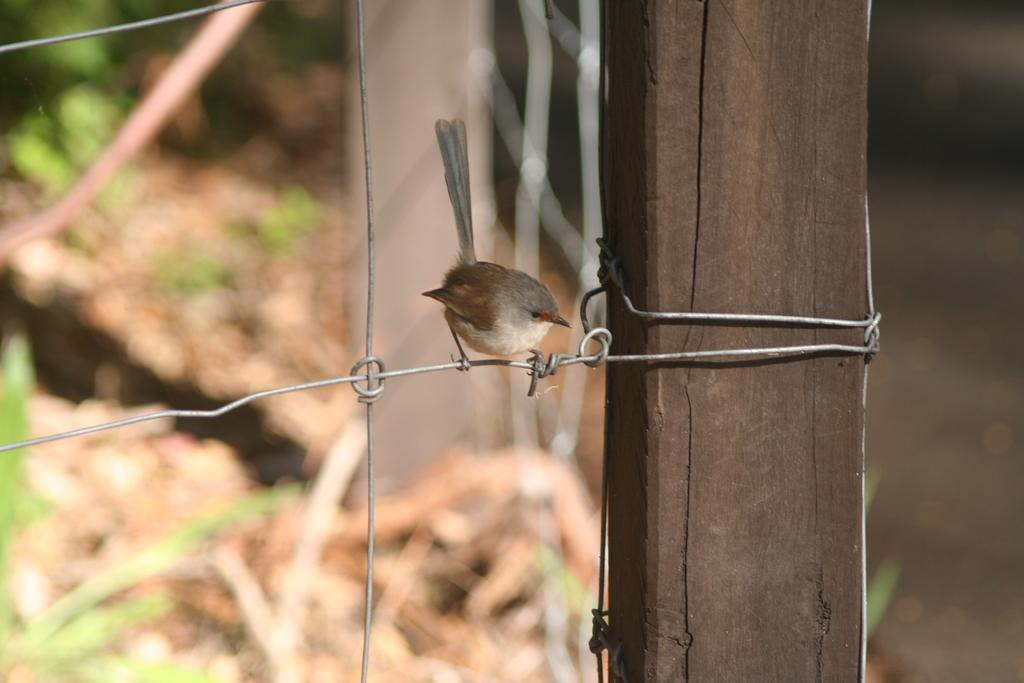What type of bird is in the image? There is a nightingale in the image. Where is the nightingale positioned in the image? The nightingale is standing on a steel wire. What can be seen on the right side of the image? There is a wood on the right side of the image. How are the steel wires connected in the image? The steel wires are connected to the wood. What type of vegetation is on the left side of the image? There is grass on the left side of the image. What type of agreement is being signed by the nightingale in the image? There is no agreement being signed in the image; it features a nightingale standing on a steel wire. How many balls can be seen in the image? There are no balls present in the image. 